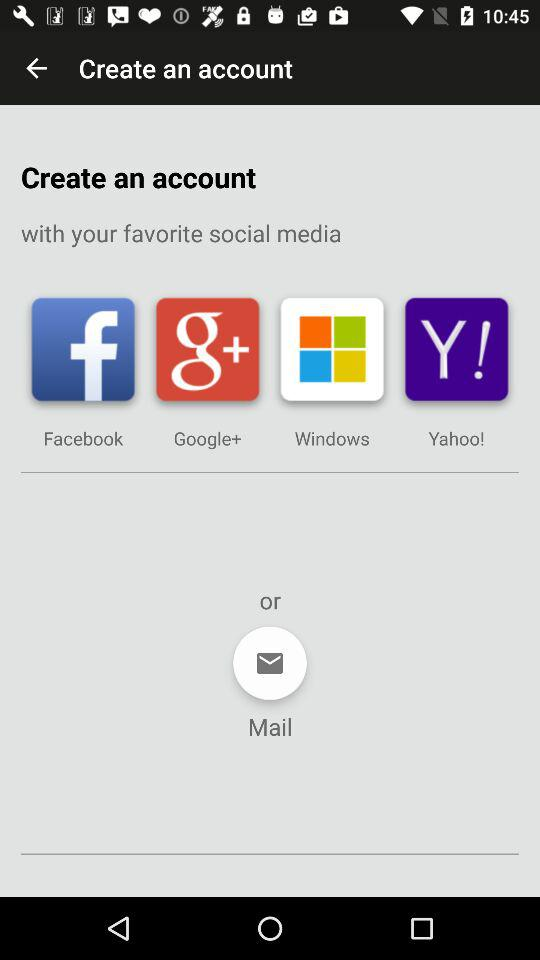How many social media platforms are available for creating an account?
Answer the question using a single word or phrase. 4 